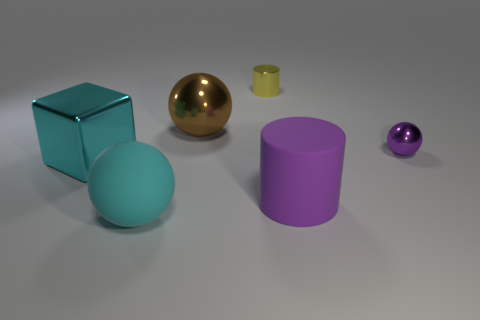Subtract all big cyan rubber balls. How many balls are left? 2 Subtract all purple cylinders. How many cylinders are left? 1 Subtract 3 spheres. How many spheres are left? 0 Subtract all green cubes. How many brown cylinders are left? 0 Add 4 large cylinders. How many objects exist? 10 Subtract 0 yellow balls. How many objects are left? 6 Subtract all cubes. How many objects are left? 5 Subtract all purple cylinders. Subtract all cyan cubes. How many cylinders are left? 1 Subtract all blue rubber cylinders. Subtract all big purple things. How many objects are left? 5 Add 2 big purple rubber objects. How many big purple rubber objects are left? 3 